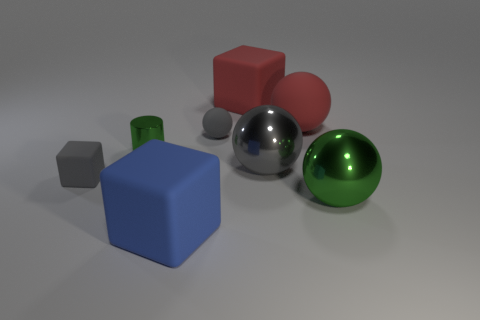Is the number of big gray metallic balls less than the number of tiny gray rubber cylinders?
Your answer should be very brief. No. What number of other things are the same material as the green ball?
Offer a very short reply. 2. The red object that is the same shape as the large gray metallic thing is what size?
Your response must be concise. Large. Does the big block behind the green shiny ball have the same material as the small green thing that is to the left of the large gray object?
Offer a terse response. No. Are there fewer matte objects that are in front of the large rubber sphere than gray balls?
Ensure brevity in your answer.  No. Is there any other thing that is the same shape as the gray metal thing?
Your response must be concise. Yes. There is a tiny matte thing that is the same shape as the gray metal thing; what is its color?
Make the answer very short. Gray. There is a ball that is on the left side of the red block; does it have the same size as the large red matte cube?
Provide a succinct answer. No. What size is the rubber block that is behind the gray matte object that is left of the blue thing?
Offer a very short reply. Large. Does the small cylinder have the same material as the tiny gray thing that is right of the large blue thing?
Provide a succinct answer. No. 